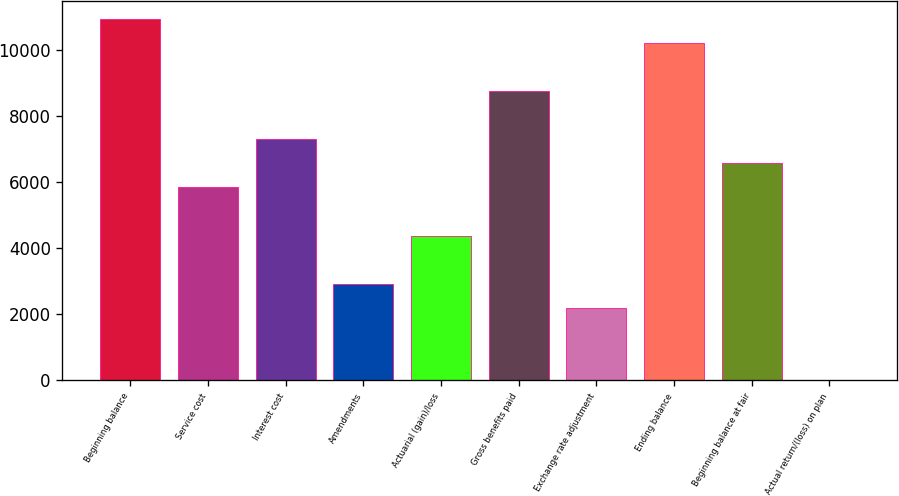<chart> <loc_0><loc_0><loc_500><loc_500><bar_chart><fcel>Beginning balance<fcel>Service cost<fcel>Interest cost<fcel>Amendments<fcel>Actuarial (gain)/loss<fcel>Gross benefits paid<fcel>Exchange rate adjustment<fcel>Ending balance<fcel>Beginning balance at fair<fcel>Actual return/(loss) on plan<nl><fcel>10958.5<fcel>5845<fcel>7306<fcel>2923<fcel>4384<fcel>8767<fcel>2192.5<fcel>10228<fcel>6575.5<fcel>1<nl></chart> 